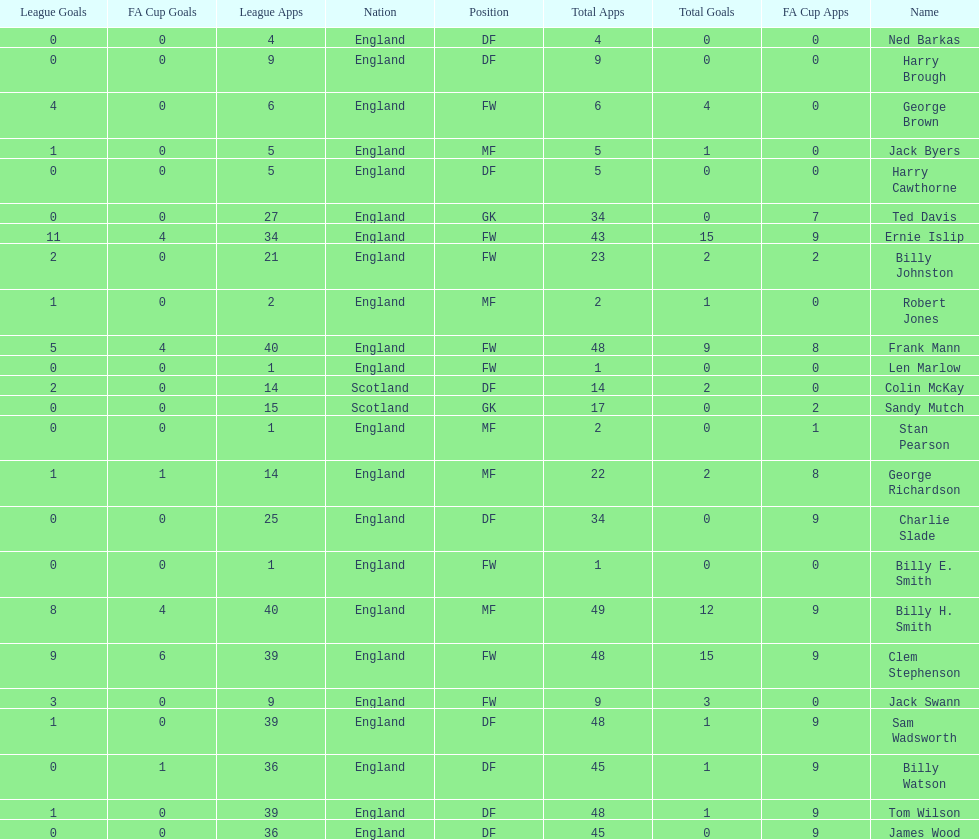Would you mind parsing the complete table? {'header': ['League Goals', 'FA Cup Goals', 'League Apps', 'Nation', 'Position', 'Total Apps', 'Total Goals', 'FA Cup Apps', 'Name'], 'rows': [['0', '0', '4', 'England', 'DF', '4', '0', '0', 'Ned Barkas'], ['0', '0', '9', 'England', 'DF', '9', '0', '0', 'Harry Brough'], ['4', '0', '6', 'England', 'FW', '6', '4', '0', 'George Brown'], ['1', '0', '5', 'England', 'MF', '5', '1', '0', 'Jack Byers'], ['0', '0', '5', 'England', 'DF', '5', '0', '0', 'Harry Cawthorne'], ['0', '0', '27', 'England', 'GK', '34', '0', '7', 'Ted Davis'], ['11', '4', '34', 'England', 'FW', '43', '15', '9', 'Ernie Islip'], ['2', '0', '21', 'England', 'FW', '23', '2', '2', 'Billy Johnston'], ['1', '0', '2', 'England', 'MF', '2', '1', '0', 'Robert Jones'], ['5', '4', '40', 'England', 'FW', '48', '9', '8', 'Frank Mann'], ['0', '0', '1', 'England', 'FW', '1', '0', '0', 'Len Marlow'], ['2', '0', '14', 'Scotland', 'DF', '14', '2', '0', 'Colin McKay'], ['0', '0', '15', 'Scotland', 'GK', '17', '0', '2', 'Sandy Mutch'], ['0', '0', '1', 'England', 'MF', '2', '0', '1', 'Stan Pearson'], ['1', '1', '14', 'England', 'MF', '22', '2', '8', 'George Richardson'], ['0', '0', '25', 'England', 'DF', '34', '0', '9', 'Charlie Slade'], ['0', '0', '1', 'England', 'FW', '1', '0', '0', 'Billy E. Smith'], ['8', '4', '40', 'England', 'MF', '49', '12', '9', 'Billy H. Smith'], ['9', '6', '39', 'England', 'FW', '48', '15', '9', 'Clem Stephenson'], ['3', '0', '9', 'England', 'FW', '9', '3', '0', 'Jack Swann'], ['1', '0', '39', 'England', 'DF', '48', '1', '9', 'Sam Wadsworth'], ['0', '1', '36', 'England', 'DF', '45', '1', '9', 'Billy Watson'], ['1', '0', '39', 'England', 'DF', '48', '1', '9', 'Tom Wilson'], ['0', '0', '36', 'England', 'DF', '45', '0', '9', 'James Wood']]} What is the average number of scotland's total apps? 15.5. 